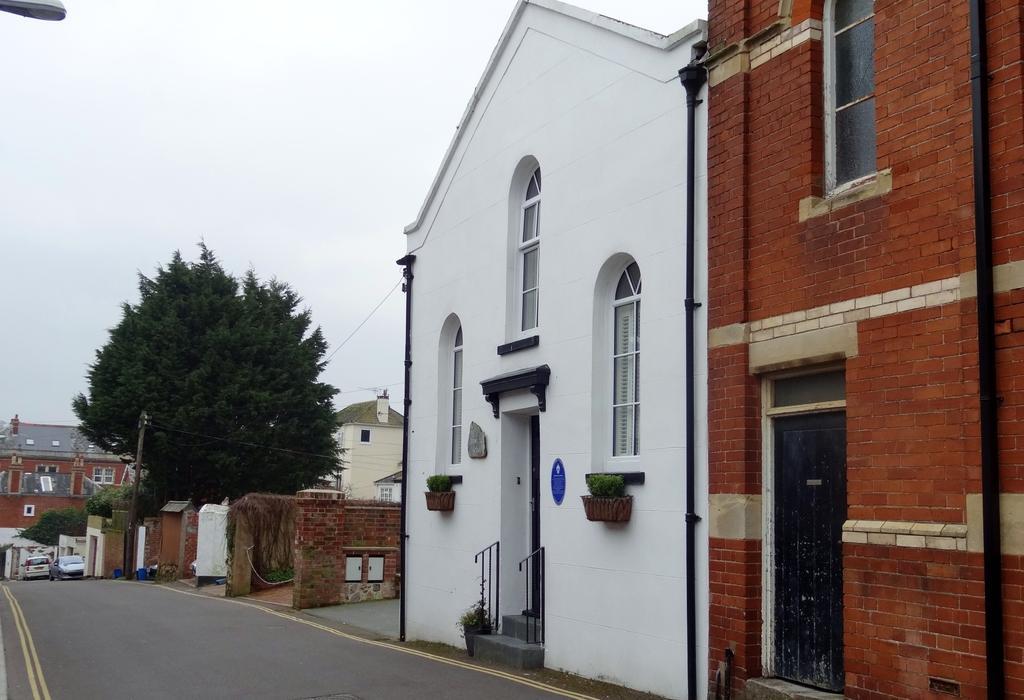Can you describe this image briefly? In the picture we can see some house buildings, which are red in color with a brick and beside we can see a house which is white in color with some windows to it and besides to it, we can see some walls and tree and some building and near to it we can see a road and some cars on it and we can also see a sky. 